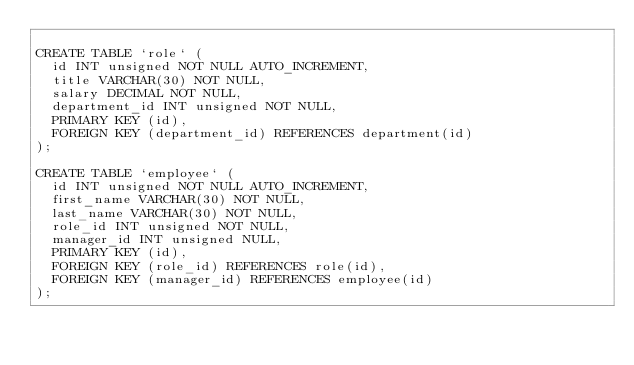Convert code to text. <code><loc_0><loc_0><loc_500><loc_500><_SQL_>
CREATE TABLE `role` (
  id INT unsigned NOT NULL AUTO_INCREMENT,
  title VARCHAR(30) NOT NULL,
  salary DECIMAL NOT NULL,
  department_id INT unsigned NOT NULL,
  PRIMARY KEY (id),
  FOREIGN KEY (department_id) REFERENCES department(id)
);

CREATE TABLE `employee` (
  id INT unsigned NOT NULL AUTO_INCREMENT,
  first_name VARCHAR(30) NOT NULL,
  last_name VARCHAR(30) NOT NULL,
  role_id INT unsigned NOT NULL,
  manager_id INT unsigned NULL,
  PRIMARY KEY (id),
  FOREIGN KEY (role_id) REFERENCES role(id),
  FOREIGN KEY (manager_id) REFERENCES employee(id)
);
</code> 